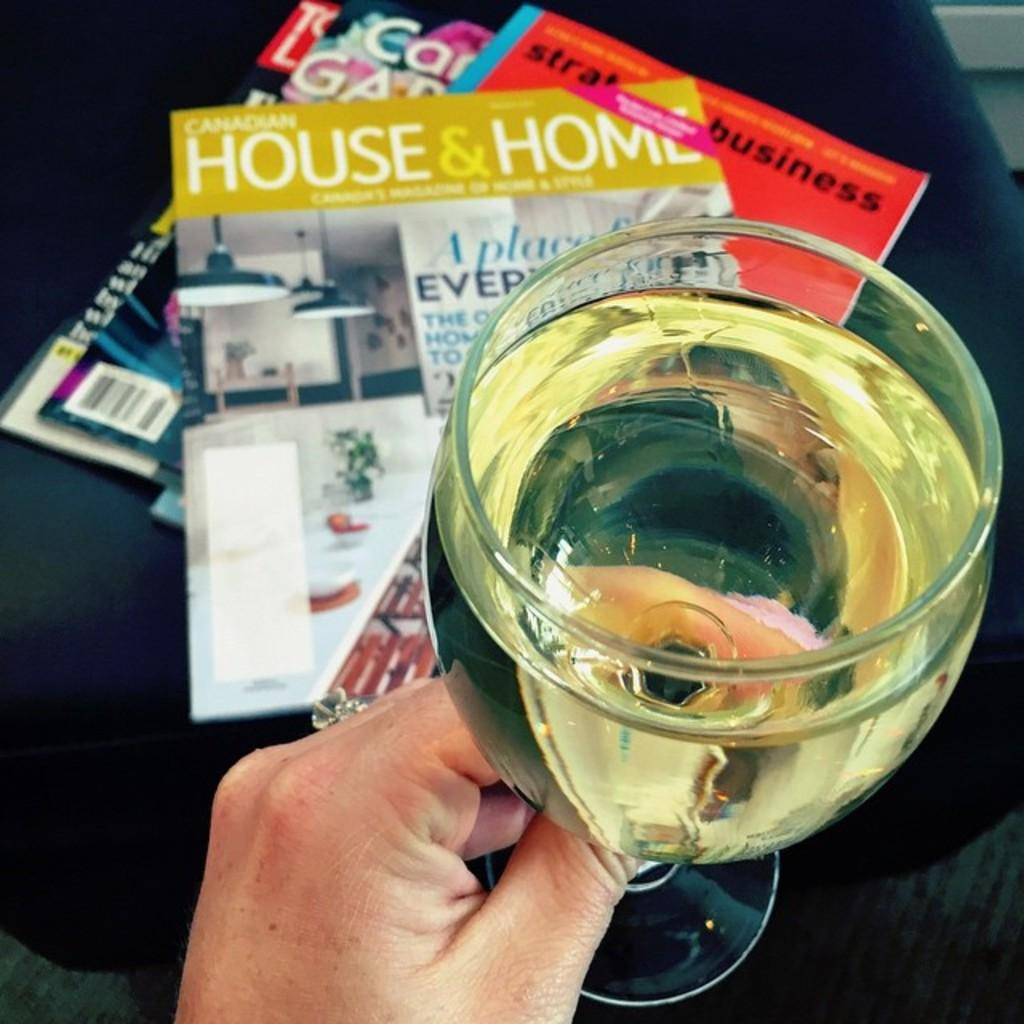<image>
Write a terse but informative summary of the picture. A person enjoys a beverage net to a stack of magazines including House & Home. 